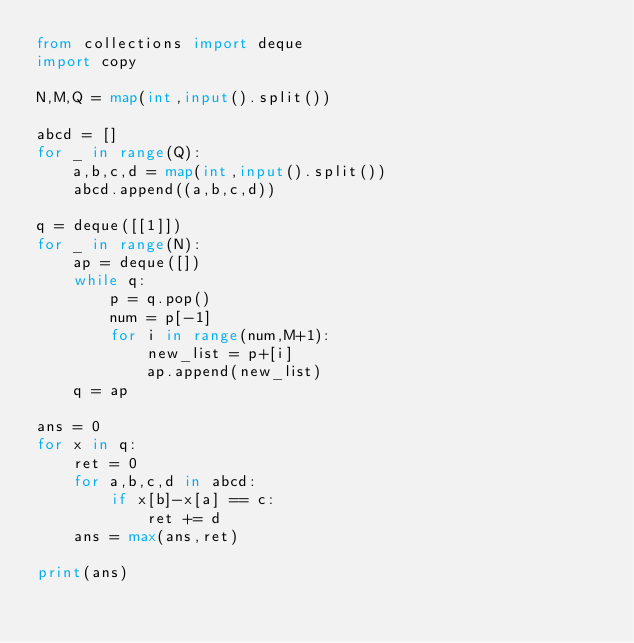<code> <loc_0><loc_0><loc_500><loc_500><_Python_>from collections import deque
import copy

N,M,Q = map(int,input().split())

abcd = []
for _ in range(Q):
    a,b,c,d = map(int,input().split())
    abcd.append((a,b,c,d))
    
q = deque([[1]])
for _ in range(N):
    ap = deque([])
    while q:
        p = q.pop()
        num = p[-1]
        for i in range(num,M+1):
            new_list = p+[i]
            ap.append(new_list)
    q = ap
    
ans = 0
for x in q:
    ret = 0
    for a,b,c,d in abcd:
        if x[b]-x[a] == c:
            ret += d
    ans = max(ans,ret)
    
print(ans)
</code> 